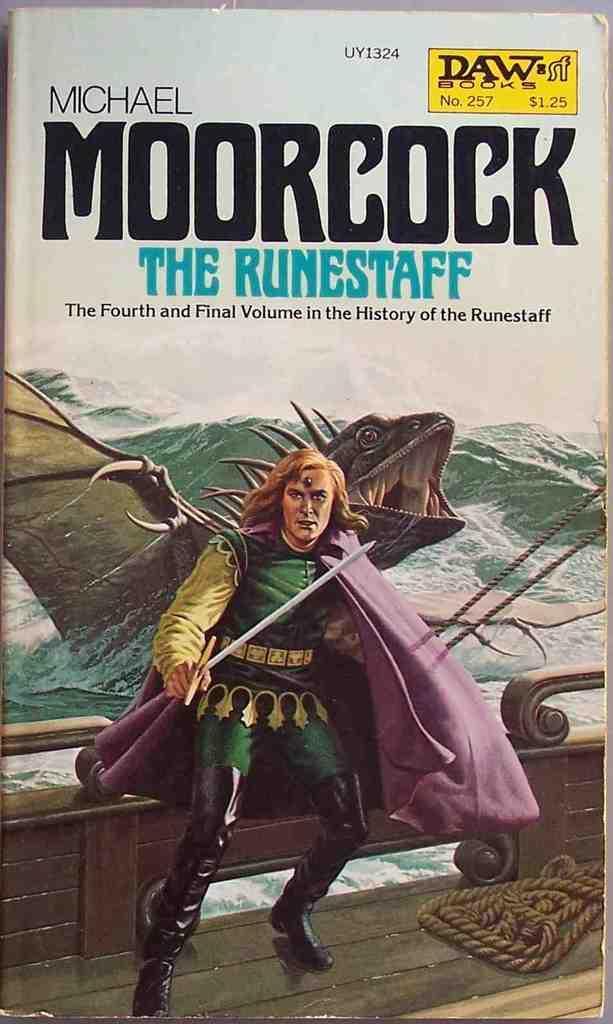Describe this image in one or two sentences. This image looks like a front page of a book in which I can see a man in costume, animal, mountains, text and the sky. 